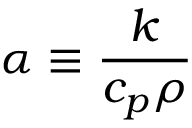Convert formula to latex. <formula><loc_0><loc_0><loc_500><loc_500>\alpha \equiv \frac { k } { c _ { p } \rho }</formula> 